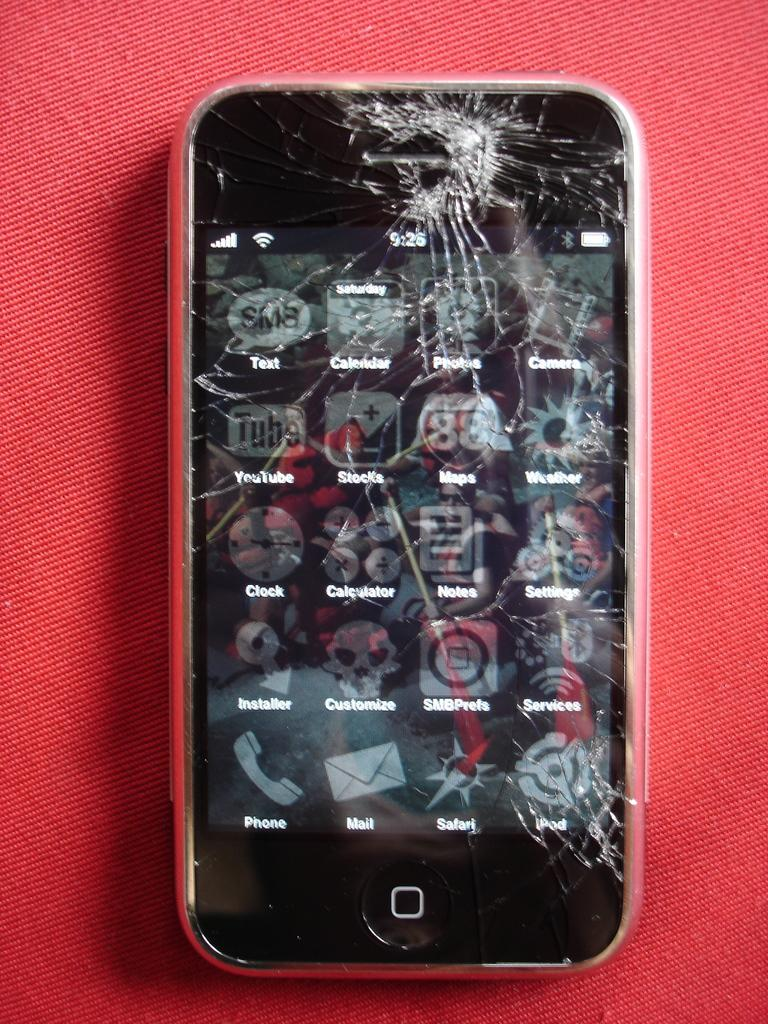<image>
Summarize the visual content of the image. Cracked iphone that shows the home screen and a full battery 